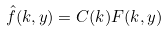Convert formula to latex. <formula><loc_0><loc_0><loc_500><loc_500>\hat { f } ( k , y ) = C ( k ) F ( k , y )</formula> 